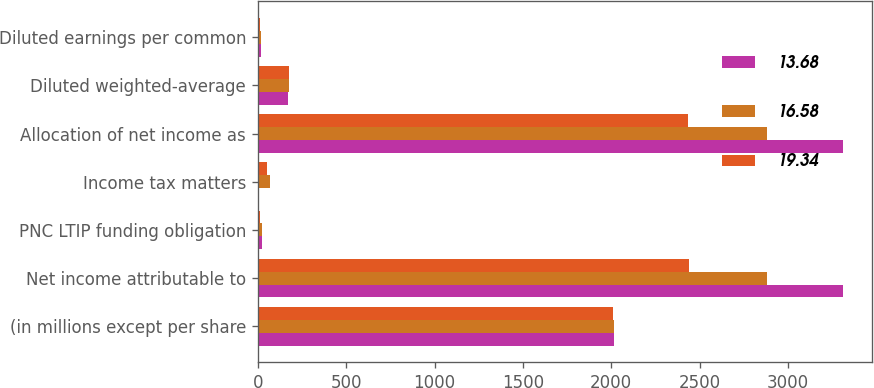Convert chart. <chart><loc_0><loc_0><loc_500><loc_500><stacked_bar_chart><ecel><fcel>(in millions except per share<fcel>Net income attributable to<fcel>PNC LTIP funding obligation<fcel>Income tax matters<fcel>Allocation of net income as<fcel>Diluted weighted-average<fcel>Diluted earnings per common<nl><fcel>13.68<fcel>2014<fcel>3310<fcel>25<fcel>9<fcel>3310<fcel>171.1<fcel>19.25<nl><fcel>16.58<fcel>2013<fcel>2882<fcel>23<fcel>69<fcel>2882<fcel>173.8<fcel>16.87<nl><fcel>19.34<fcel>2012<fcel>2438<fcel>14<fcel>50<fcel>2435<fcel>178<fcel>13.79<nl></chart> 